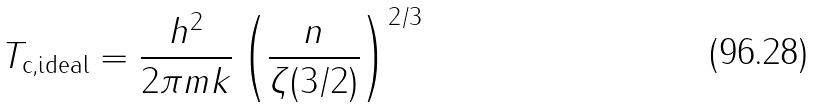<formula> <loc_0><loc_0><loc_500><loc_500>T _ { \text {c,ideal} } = \frac { h ^ { 2 } } { 2 \pi m k } \left ( \frac { n } { \zeta ( 3 / 2 ) } \right ) ^ { 2 / 3 }</formula> 